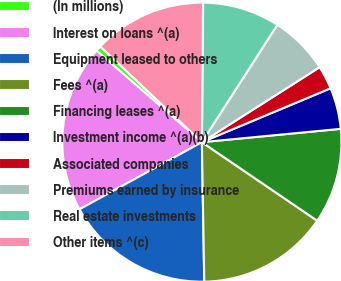<chart> <loc_0><loc_0><loc_500><loc_500><pie_chart><fcel>(In millions)<fcel>Interest on loans ^(a)<fcel>Equipment leased to others<fcel>Fees ^(a)<fcel>Financing leases ^(a)<fcel>Investment income ^(a)(b)<fcel>Associated companies<fcel>Premiums earned by insurance<fcel>Real estate investments<fcel>Other items ^(c)<nl><fcel>0.63%<fcel>19.37%<fcel>17.29%<fcel>15.21%<fcel>11.04%<fcel>4.79%<fcel>2.71%<fcel>6.88%<fcel>8.96%<fcel>13.12%<nl></chart> 